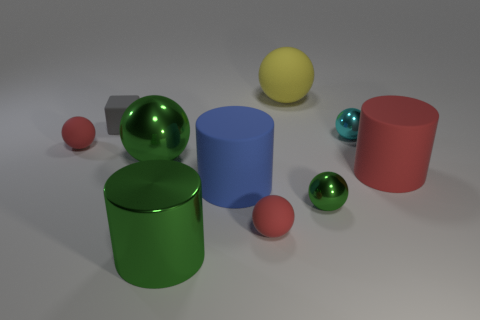What is the thing that is left of the gray rubber object made of?
Provide a succinct answer. Rubber. Are there fewer green metallic balls that are on the right side of the large green ball than yellow balls?
Keep it short and to the point. No. There is a large green metallic thing behind the thing that is right of the tiny cyan shiny object; what is its shape?
Provide a short and direct response. Sphere. What color is the small matte block?
Provide a short and direct response. Gray. What number of other things are there of the same size as the gray matte cube?
Ensure brevity in your answer.  4. There is a tiny object that is to the right of the gray matte object and behind the big red cylinder; what material is it?
Make the answer very short. Metal. Do the ball that is behind the cyan metallic sphere and the blue matte cylinder have the same size?
Your answer should be very brief. Yes. Do the cube and the big metal cylinder have the same color?
Ensure brevity in your answer.  No. How many things are both in front of the tiny gray object and to the left of the big blue rubber thing?
Offer a terse response. 3. How many gray matte cubes are to the right of the gray matte object that is to the left of the big rubber cylinder on the right side of the cyan shiny sphere?
Your response must be concise. 0. 